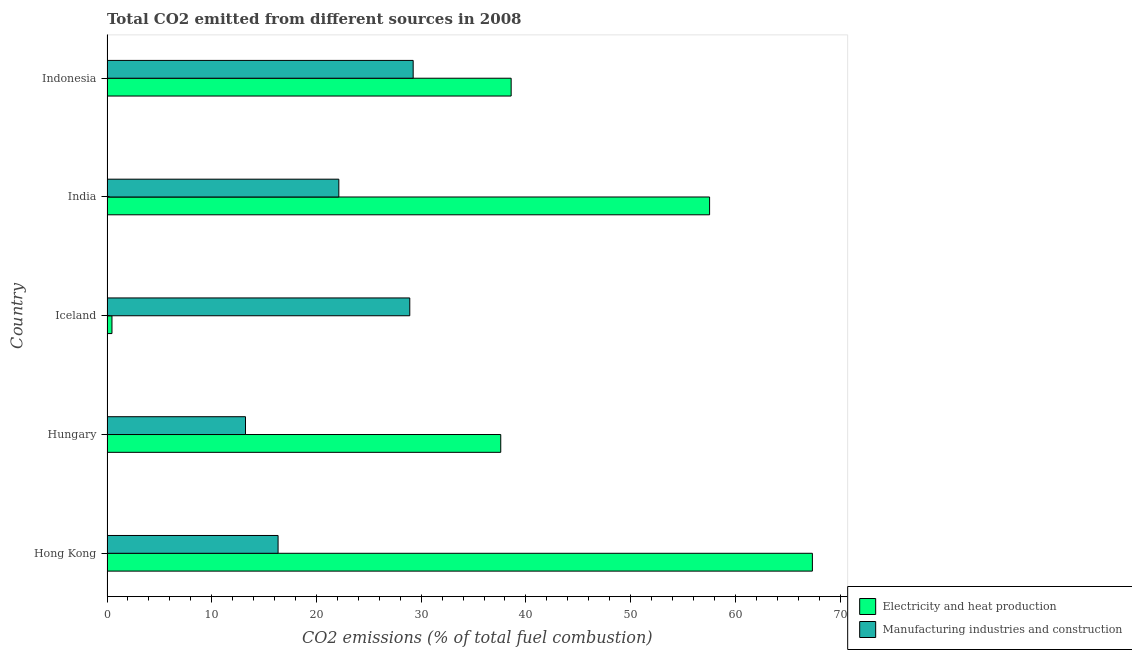Are the number of bars per tick equal to the number of legend labels?
Give a very brief answer. Yes. Are the number of bars on each tick of the Y-axis equal?
Give a very brief answer. Yes. How many bars are there on the 3rd tick from the top?
Make the answer very short. 2. What is the label of the 3rd group of bars from the top?
Give a very brief answer. Iceland. What is the co2 emissions due to manufacturing industries in Hungary?
Offer a terse response. 13.22. Across all countries, what is the maximum co2 emissions due to manufacturing industries?
Offer a very short reply. 29.23. Across all countries, what is the minimum co2 emissions due to manufacturing industries?
Your answer should be compact. 13.22. In which country was the co2 emissions due to electricity and heat production maximum?
Your response must be concise. Hong Kong. In which country was the co2 emissions due to manufacturing industries minimum?
Offer a very short reply. Hungary. What is the total co2 emissions due to electricity and heat production in the graph?
Provide a short and direct response. 201.55. What is the difference between the co2 emissions due to manufacturing industries in Iceland and the co2 emissions due to electricity and heat production in Indonesia?
Provide a short and direct response. -9.68. What is the average co2 emissions due to electricity and heat production per country?
Offer a terse response. 40.31. What is the difference between the co2 emissions due to electricity and heat production and co2 emissions due to manufacturing industries in India?
Offer a terse response. 35.4. What is the difference between the highest and the second highest co2 emissions due to electricity and heat production?
Give a very brief answer. 9.82. What is the difference between the highest and the lowest co2 emissions due to manufacturing industries?
Give a very brief answer. 16.01. Is the sum of the co2 emissions due to electricity and heat production in Iceland and Indonesia greater than the maximum co2 emissions due to manufacturing industries across all countries?
Ensure brevity in your answer.  Yes. What does the 2nd bar from the top in Hungary represents?
Your answer should be very brief. Electricity and heat production. What does the 1st bar from the bottom in India represents?
Keep it short and to the point. Electricity and heat production. How many bars are there?
Your answer should be very brief. 10. Does the graph contain any zero values?
Make the answer very short. No. How many legend labels are there?
Your answer should be very brief. 2. What is the title of the graph?
Offer a very short reply. Total CO2 emitted from different sources in 2008. What is the label or title of the X-axis?
Give a very brief answer. CO2 emissions (% of total fuel combustion). What is the label or title of the Y-axis?
Your answer should be very brief. Country. What is the CO2 emissions (% of total fuel combustion) of Electricity and heat production in Hong Kong?
Offer a terse response. 67.35. What is the CO2 emissions (% of total fuel combustion) of Manufacturing industries and construction in Hong Kong?
Offer a terse response. 16.34. What is the CO2 emissions (% of total fuel combustion) of Electricity and heat production in Hungary?
Your answer should be compact. 37.6. What is the CO2 emissions (% of total fuel combustion) of Manufacturing industries and construction in Hungary?
Keep it short and to the point. 13.22. What is the CO2 emissions (% of total fuel combustion) in Electricity and heat production in Iceland?
Ensure brevity in your answer.  0.47. What is the CO2 emissions (% of total fuel combustion) in Manufacturing industries and construction in Iceland?
Provide a succinct answer. 28.91. What is the CO2 emissions (% of total fuel combustion) of Electricity and heat production in India?
Make the answer very short. 57.54. What is the CO2 emissions (% of total fuel combustion) of Manufacturing industries and construction in India?
Your response must be concise. 22.14. What is the CO2 emissions (% of total fuel combustion) of Electricity and heat production in Indonesia?
Give a very brief answer. 38.59. What is the CO2 emissions (% of total fuel combustion) in Manufacturing industries and construction in Indonesia?
Your answer should be very brief. 29.23. Across all countries, what is the maximum CO2 emissions (% of total fuel combustion) of Electricity and heat production?
Make the answer very short. 67.35. Across all countries, what is the maximum CO2 emissions (% of total fuel combustion) in Manufacturing industries and construction?
Offer a terse response. 29.23. Across all countries, what is the minimum CO2 emissions (% of total fuel combustion) in Electricity and heat production?
Offer a very short reply. 0.47. Across all countries, what is the minimum CO2 emissions (% of total fuel combustion) in Manufacturing industries and construction?
Offer a very short reply. 13.22. What is the total CO2 emissions (% of total fuel combustion) of Electricity and heat production in the graph?
Your response must be concise. 201.55. What is the total CO2 emissions (% of total fuel combustion) in Manufacturing industries and construction in the graph?
Provide a succinct answer. 109.84. What is the difference between the CO2 emissions (% of total fuel combustion) in Electricity and heat production in Hong Kong and that in Hungary?
Provide a short and direct response. 29.76. What is the difference between the CO2 emissions (% of total fuel combustion) of Manufacturing industries and construction in Hong Kong and that in Hungary?
Your response must be concise. 3.11. What is the difference between the CO2 emissions (% of total fuel combustion) in Electricity and heat production in Hong Kong and that in Iceland?
Make the answer very short. 66.88. What is the difference between the CO2 emissions (% of total fuel combustion) in Manufacturing industries and construction in Hong Kong and that in Iceland?
Keep it short and to the point. -12.57. What is the difference between the CO2 emissions (% of total fuel combustion) of Electricity and heat production in Hong Kong and that in India?
Give a very brief answer. 9.82. What is the difference between the CO2 emissions (% of total fuel combustion) in Manufacturing industries and construction in Hong Kong and that in India?
Offer a very short reply. -5.8. What is the difference between the CO2 emissions (% of total fuel combustion) of Electricity and heat production in Hong Kong and that in Indonesia?
Provide a short and direct response. 28.76. What is the difference between the CO2 emissions (% of total fuel combustion) in Manufacturing industries and construction in Hong Kong and that in Indonesia?
Provide a short and direct response. -12.9. What is the difference between the CO2 emissions (% of total fuel combustion) of Electricity and heat production in Hungary and that in Iceland?
Offer a very short reply. 37.12. What is the difference between the CO2 emissions (% of total fuel combustion) in Manufacturing industries and construction in Hungary and that in Iceland?
Ensure brevity in your answer.  -15.69. What is the difference between the CO2 emissions (% of total fuel combustion) of Electricity and heat production in Hungary and that in India?
Provide a succinct answer. -19.94. What is the difference between the CO2 emissions (% of total fuel combustion) of Manufacturing industries and construction in Hungary and that in India?
Your answer should be very brief. -8.91. What is the difference between the CO2 emissions (% of total fuel combustion) of Electricity and heat production in Hungary and that in Indonesia?
Provide a succinct answer. -0.99. What is the difference between the CO2 emissions (% of total fuel combustion) of Manufacturing industries and construction in Hungary and that in Indonesia?
Offer a terse response. -16.01. What is the difference between the CO2 emissions (% of total fuel combustion) of Electricity and heat production in Iceland and that in India?
Make the answer very short. -57.06. What is the difference between the CO2 emissions (% of total fuel combustion) of Manufacturing industries and construction in Iceland and that in India?
Give a very brief answer. 6.77. What is the difference between the CO2 emissions (% of total fuel combustion) of Electricity and heat production in Iceland and that in Indonesia?
Your answer should be compact. -38.12. What is the difference between the CO2 emissions (% of total fuel combustion) in Manufacturing industries and construction in Iceland and that in Indonesia?
Offer a very short reply. -0.32. What is the difference between the CO2 emissions (% of total fuel combustion) of Electricity and heat production in India and that in Indonesia?
Give a very brief answer. 18.95. What is the difference between the CO2 emissions (% of total fuel combustion) in Manufacturing industries and construction in India and that in Indonesia?
Make the answer very short. -7.1. What is the difference between the CO2 emissions (% of total fuel combustion) of Electricity and heat production in Hong Kong and the CO2 emissions (% of total fuel combustion) of Manufacturing industries and construction in Hungary?
Your answer should be very brief. 54.13. What is the difference between the CO2 emissions (% of total fuel combustion) in Electricity and heat production in Hong Kong and the CO2 emissions (% of total fuel combustion) in Manufacturing industries and construction in Iceland?
Offer a terse response. 38.44. What is the difference between the CO2 emissions (% of total fuel combustion) in Electricity and heat production in Hong Kong and the CO2 emissions (% of total fuel combustion) in Manufacturing industries and construction in India?
Your response must be concise. 45.22. What is the difference between the CO2 emissions (% of total fuel combustion) of Electricity and heat production in Hong Kong and the CO2 emissions (% of total fuel combustion) of Manufacturing industries and construction in Indonesia?
Your response must be concise. 38.12. What is the difference between the CO2 emissions (% of total fuel combustion) in Electricity and heat production in Hungary and the CO2 emissions (% of total fuel combustion) in Manufacturing industries and construction in Iceland?
Your response must be concise. 8.69. What is the difference between the CO2 emissions (% of total fuel combustion) of Electricity and heat production in Hungary and the CO2 emissions (% of total fuel combustion) of Manufacturing industries and construction in India?
Make the answer very short. 15.46. What is the difference between the CO2 emissions (% of total fuel combustion) of Electricity and heat production in Hungary and the CO2 emissions (% of total fuel combustion) of Manufacturing industries and construction in Indonesia?
Make the answer very short. 8.36. What is the difference between the CO2 emissions (% of total fuel combustion) in Electricity and heat production in Iceland and the CO2 emissions (% of total fuel combustion) in Manufacturing industries and construction in India?
Ensure brevity in your answer.  -21.66. What is the difference between the CO2 emissions (% of total fuel combustion) in Electricity and heat production in Iceland and the CO2 emissions (% of total fuel combustion) in Manufacturing industries and construction in Indonesia?
Provide a succinct answer. -28.76. What is the difference between the CO2 emissions (% of total fuel combustion) of Electricity and heat production in India and the CO2 emissions (% of total fuel combustion) of Manufacturing industries and construction in Indonesia?
Offer a very short reply. 28.3. What is the average CO2 emissions (% of total fuel combustion) in Electricity and heat production per country?
Make the answer very short. 40.31. What is the average CO2 emissions (% of total fuel combustion) of Manufacturing industries and construction per country?
Keep it short and to the point. 21.97. What is the difference between the CO2 emissions (% of total fuel combustion) in Electricity and heat production and CO2 emissions (% of total fuel combustion) in Manufacturing industries and construction in Hong Kong?
Ensure brevity in your answer.  51.02. What is the difference between the CO2 emissions (% of total fuel combustion) in Electricity and heat production and CO2 emissions (% of total fuel combustion) in Manufacturing industries and construction in Hungary?
Ensure brevity in your answer.  24.37. What is the difference between the CO2 emissions (% of total fuel combustion) of Electricity and heat production and CO2 emissions (% of total fuel combustion) of Manufacturing industries and construction in Iceland?
Ensure brevity in your answer.  -28.44. What is the difference between the CO2 emissions (% of total fuel combustion) in Electricity and heat production and CO2 emissions (% of total fuel combustion) in Manufacturing industries and construction in India?
Your response must be concise. 35.4. What is the difference between the CO2 emissions (% of total fuel combustion) in Electricity and heat production and CO2 emissions (% of total fuel combustion) in Manufacturing industries and construction in Indonesia?
Your answer should be compact. 9.36. What is the ratio of the CO2 emissions (% of total fuel combustion) of Electricity and heat production in Hong Kong to that in Hungary?
Ensure brevity in your answer.  1.79. What is the ratio of the CO2 emissions (% of total fuel combustion) of Manufacturing industries and construction in Hong Kong to that in Hungary?
Offer a very short reply. 1.24. What is the ratio of the CO2 emissions (% of total fuel combustion) in Electricity and heat production in Hong Kong to that in Iceland?
Offer a terse response. 142.12. What is the ratio of the CO2 emissions (% of total fuel combustion) in Manufacturing industries and construction in Hong Kong to that in Iceland?
Your answer should be compact. 0.56. What is the ratio of the CO2 emissions (% of total fuel combustion) of Electricity and heat production in Hong Kong to that in India?
Make the answer very short. 1.17. What is the ratio of the CO2 emissions (% of total fuel combustion) of Manufacturing industries and construction in Hong Kong to that in India?
Your answer should be compact. 0.74. What is the ratio of the CO2 emissions (% of total fuel combustion) of Electricity and heat production in Hong Kong to that in Indonesia?
Your answer should be very brief. 1.75. What is the ratio of the CO2 emissions (% of total fuel combustion) in Manufacturing industries and construction in Hong Kong to that in Indonesia?
Ensure brevity in your answer.  0.56. What is the ratio of the CO2 emissions (% of total fuel combustion) of Electricity and heat production in Hungary to that in Iceland?
Offer a terse response. 79.33. What is the ratio of the CO2 emissions (% of total fuel combustion) in Manufacturing industries and construction in Hungary to that in Iceland?
Give a very brief answer. 0.46. What is the ratio of the CO2 emissions (% of total fuel combustion) in Electricity and heat production in Hungary to that in India?
Give a very brief answer. 0.65. What is the ratio of the CO2 emissions (% of total fuel combustion) of Manufacturing industries and construction in Hungary to that in India?
Provide a short and direct response. 0.6. What is the ratio of the CO2 emissions (% of total fuel combustion) in Electricity and heat production in Hungary to that in Indonesia?
Offer a terse response. 0.97. What is the ratio of the CO2 emissions (% of total fuel combustion) of Manufacturing industries and construction in Hungary to that in Indonesia?
Make the answer very short. 0.45. What is the ratio of the CO2 emissions (% of total fuel combustion) of Electricity and heat production in Iceland to that in India?
Offer a terse response. 0.01. What is the ratio of the CO2 emissions (% of total fuel combustion) in Manufacturing industries and construction in Iceland to that in India?
Offer a very short reply. 1.31. What is the ratio of the CO2 emissions (% of total fuel combustion) in Electricity and heat production in Iceland to that in Indonesia?
Make the answer very short. 0.01. What is the ratio of the CO2 emissions (% of total fuel combustion) of Manufacturing industries and construction in Iceland to that in Indonesia?
Make the answer very short. 0.99. What is the ratio of the CO2 emissions (% of total fuel combustion) of Electricity and heat production in India to that in Indonesia?
Your response must be concise. 1.49. What is the ratio of the CO2 emissions (% of total fuel combustion) in Manufacturing industries and construction in India to that in Indonesia?
Your answer should be compact. 0.76. What is the difference between the highest and the second highest CO2 emissions (% of total fuel combustion) of Electricity and heat production?
Make the answer very short. 9.82. What is the difference between the highest and the second highest CO2 emissions (% of total fuel combustion) in Manufacturing industries and construction?
Make the answer very short. 0.32. What is the difference between the highest and the lowest CO2 emissions (% of total fuel combustion) of Electricity and heat production?
Keep it short and to the point. 66.88. What is the difference between the highest and the lowest CO2 emissions (% of total fuel combustion) of Manufacturing industries and construction?
Your response must be concise. 16.01. 